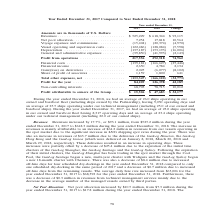From Gaslog's financial document, How many ships are operating in 2018 and 2017 on average respectively? The document shows two values: 26.0 and 23.0. From the document: "ear ended December 31, 2018, we had an average of 26.0 ships operating in our owned and bareboat fleet (including ships owned by the Partnership), hav..." Also, What accounted for the change in revenue? Mainly attributable to an increase of $64.2 million in revenues from our vessels operating in the spot market due to the significant increase in LNG shipping spot rates during the year.. The document states: "ded December 31, 2018. The increase in revenues is mainly attributable to an increase of $64.2 million in revenues from our vessels operating in the s..." Also, What was the reason for the increase in operating days? Based on the financial document, the answer is Due to the deliveries of the GasLog Houston, the GasLog Hong Kong and the GasLog Genoa. Additionally, In which year has a higher financial income? According to the financial document, 2018. The relevant text states: "Year ended December 31, 2017 2018 Change..." Also, can you calculate: What was the change in average daily hire rate from 2017 to 2018? Based on the calculation: $68,392 - $63,006 , the result is 5386 (in thousands). This is based on the information: "$63,006 for the year ended December 31, 2017 to $68,392 for the year ended December 31, 2018. Furthermore, there was a decrease of $0.3 million in revenues sels. The average daily hire rate increased ..." The key data points involved are: 63,006, 68,392. Also, can you calculate: What was the percentage change in profit from 2017 to 2018? To answer this question, I need to perform calculations using the financial data. The calculation is: (126,398 - 84,209)/84,209 , which equals 50.1 (percentage). This is based on the information: "Profit for the year . 84,209 126,398 42,189 Profit for the year . 84,209 126,398 42,189..." The key data points involved are: 126,398, 84,209. 